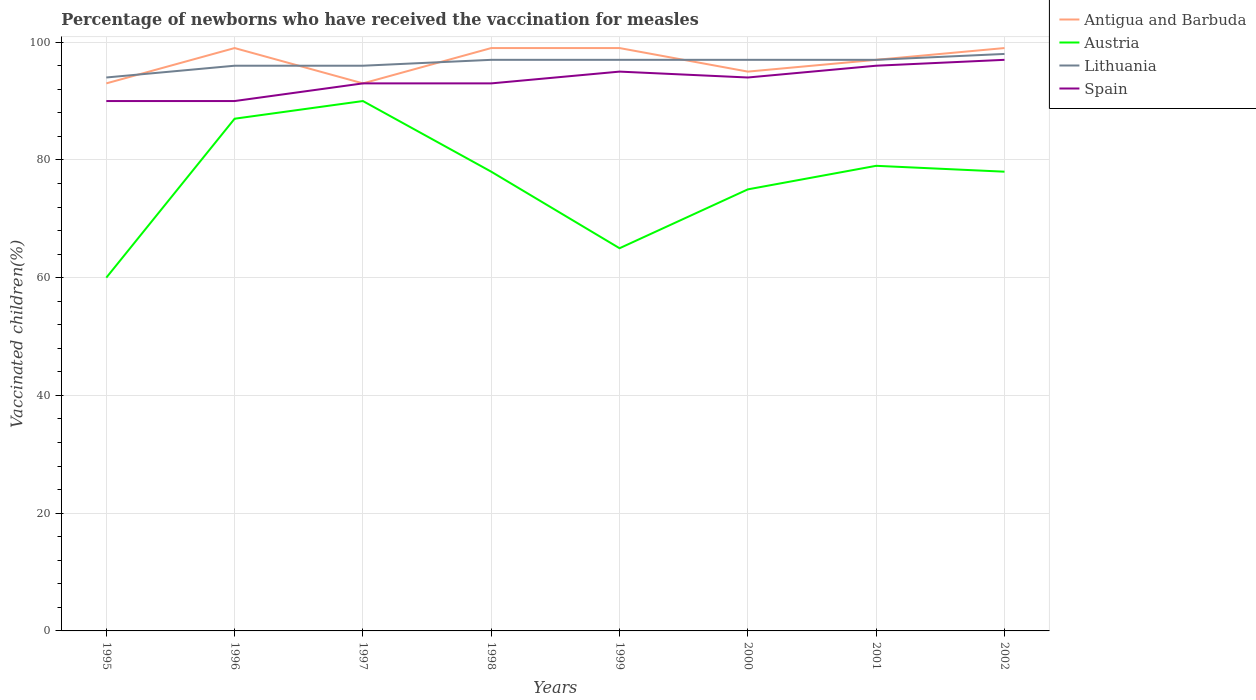Does the line corresponding to Spain intersect with the line corresponding to Antigua and Barbuda?
Keep it short and to the point. Yes. Across all years, what is the maximum percentage of vaccinated children in Spain?
Your response must be concise. 90. In which year was the percentage of vaccinated children in Spain maximum?
Your answer should be very brief. 1995. What is the difference between the highest and the second highest percentage of vaccinated children in Spain?
Provide a short and direct response. 7. How many lines are there?
Your response must be concise. 4. How many years are there in the graph?
Your answer should be very brief. 8. Are the values on the major ticks of Y-axis written in scientific E-notation?
Give a very brief answer. No. Does the graph contain any zero values?
Your answer should be compact. No. Where does the legend appear in the graph?
Your answer should be compact. Top right. How many legend labels are there?
Provide a succinct answer. 4. How are the legend labels stacked?
Make the answer very short. Vertical. What is the title of the graph?
Provide a succinct answer. Percentage of newborns who have received the vaccination for measles. Does "Algeria" appear as one of the legend labels in the graph?
Offer a terse response. No. What is the label or title of the Y-axis?
Provide a succinct answer. Vaccinated children(%). What is the Vaccinated children(%) of Antigua and Barbuda in 1995?
Keep it short and to the point. 93. What is the Vaccinated children(%) of Austria in 1995?
Your answer should be compact. 60. What is the Vaccinated children(%) in Lithuania in 1995?
Your answer should be very brief. 94. What is the Vaccinated children(%) in Spain in 1995?
Your answer should be compact. 90. What is the Vaccinated children(%) in Antigua and Barbuda in 1996?
Keep it short and to the point. 99. What is the Vaccinated children(%) of Austria in 1996?
Your answer should be very brief. 87. What is the Vaccinated children(%) in Lithuania in 1996?
Your answer should be compact. 96. What is the Vaccinated children(%) of Antigua and Barbuda in 1997?
Keep it short and to the point. 93. What is the Vaccinated children(%) in Austria in 1997?
Ensure brevity in your answer.  90. What is the Vaccinated children(%) of Lithuania in 1997?
Your response must be concise. 96. What is the Vaccinated children(%) in Spain in 1997?
Your answer should be very brief. 93. What is the Vaccinated children(%) in Lithuania in 1998?
Your answer should be compact. 97. What is the Vaccinated children(%) in Spain in 1998?
Offer a very short reply. 93. What is the Vaccinated children(%) of Antigua and Barbuda in 1999?
Your response must be concise. 99. What is the Vaccinated children(%) of Lithuania in 1999?
Keep it short and to the point. 97. What is the Vaccinated children(%) in Spain in 1999?
Give a very brief answer. 95. What is the Vaccinated children(%) in Antigua and Barbuda in 2000?
Provide a succinct answer. 95. What is the Vaccinated children(%) of Austria in 2000?
Provide a succinct answer. 75. What is the Vaccinated children(%) of Lithuania in 2000?
Your response must be concise. 97. What is the Vaccinated children(%) in Spain in 2000?
Your answer should be very brief. 94. What is the Vaccinated children(%) in Antigua and Barbuda in 2001?
Make the answer very short. 97. What is the Vaccinated children(%) in Austria in 2001?
Give a very brief answer. 79. What is the Vaccinated children(%) of Lithuania in 2001?
Keep it short and to the point. 97. What is the Vaccinated children(%) in Spain in 2001?
Provide a short and direct response. 96. What is the Vaccinated children(%) in Antigua and Barbuda in 2002?
Provide a short and direct response. 99. What is the Vaccinated children(%) in Lithuania in 2002?
Your answer should be very brief. 98. What is the Vaccinated children(%) in Spain in 2002?
Your answer should be very brief. 97. Across all years, what is the maximum Vaccinated children(%) of Antigua and Barbuda?
Provide a succinct answer. 99. Across all years, what is the maximum Vaccinated children(%) in Lithuania?
Provide a succinct answer. 98. Across all years, what is the maximum Vaccinated children(%) in Spain?
Your answer should be compact. 97. Across all years, what is the minimum Vaccinated children(%) of Antigua and Barbuda?
Your answer should be compact. 93. Across all years, what is the minimum Vaccinated children(%) in Lithuania?
Ensure brevity in your answer.  94. What is the total Vaccinated children(%) in Antigua and Barbuda in the graph?
Make the answer very short. 774. What is the total Vaccinated children(%) in Austria in the graph?
Your response must be concise. 612. What is the total Vaccinated children(%) in Lithuania in the graph?
Provide a short and direct response. 772. What is the total Vaccinated children(%) of Spain in the graph?
Your response must be concise. 748. What is the difference between the Vaccinated children(%) in Antigua and Barbuda in 1995 and that in 1996?
Provide a succinct answer. -6. What is the difference between the Vaccinated children(%) of Austria in 1995 and that in 1996?
Give a very brief answer. -27. What is the difference between the Vaccinated children(%) in Lithuania in 1995 and that in 1996?
Your response must be concise. -2. What is the difference between the Vaccinated children(%) in Spain in 1995 and that in 1996?
Offer a very short reply. 0. What is the difference between the Vaccinated children(%) of Austria in 1995 and that in 1997?
Offer a very short reply. -30. What is the difference between the Vaccinated children(%) in Lithuania in 1995 and that in 1997?
Offer a terse response. -2. What is the difference between the Vaccinated children(%) in Spain in 1995 and that in 1998?
Offer a terse response. -3. What is the difference between the Vaccinated children(%) in Antigua and Barbuda in 1995 and that in 1999?
Your answer should be very brief. -6. What is the difference between the Vaccinated children(%) of Austria in 1995 and that in 1999?
Keep it short and to the point. -5. What is the difference between the Vaccinated children(%) in Lithuania in 1995 and that in 1999?
Offer a very short reply. -3. What is the difference between the Vaccinated children(%) in Antigua and Barbuda in 1995 and that in 2000?
Offer a terse response. -2. What is the difference between the Vaccinated children(%) in Austria in 1995 and that in 2000?
Provide a short and direct response. -15. What is the difference between the Vaccinated children(%) in Lithuania in 1995 and that in 2000?
Give a very brief answer. -3. What is the difference between the Vaccinated children(%) of Antigua and Barbuda in 1995 and that in 2001?
Keep it short and to the point. -4. What is the difference between the Vaccinated children(%) in Lithuania in 1995 and that in 2001?
Give a very brief answer. -3. What is the difference between the Vaccinated children(%) in Spain in 1995 and that in 2001?
Make the answer very short. -6. What is the difference between the Vaccinated children(%) of Austria in 1995 and that in 2002?
Your answer should be compact. -18. What is the difference between the Vaccinated children(%) in Spain in 1995 and that in 2002?
Provide a succinct answer. -7. What is the difference between the Vaccinated children(%) of Antigua and Barbuda in 1996 and that in 1997?
Your response must be concise. 6. What is the difference between the Vaccinated children(%) of Austria in 1996 and that in 1997?
Offer a very short reply. -3. What is the difference between the Vaccinated children(%) of Antigua and Barbuda in 1996 and that in 1998?
Give a very brief answer. 0. What is the difference between the Vaccinated children(%) in Austria in 1996 and that in 1998?
Provide a succinct answer. 9. What is the difference between the Vaccinated children(%) of Lithuania in 1996 and that in 1998?
Your answer should be very brief. -1. What is the difference between the Vaccinated children(%) in Antigua and Barbuda in 1996 and that in 1999?
Your answer should be compact. 0. What is the difference between the Vaccinated children(%) of Austria in 1996 and that in 1999?
Provide a succinct answer. 22. What is the difference between the Vaccinated children(%) of Lithuania in 1996 and that in 1999?
Make the answer very short. -1. What is the difference between the Vaccinated children(%) in Spain in 1996 and that in 2000?
Your answer should be compact. -4. What is the difference between the Vaccinated children(%) of Antigua and Barbuda in 1996 and that in 2002?
Your response must be concise. 0. What is the difference between the Vaccinated children(%) in Lithuania in 1996 and that in 2002?
Offer a terse response. -2. What is the difference between the Vaccinated children(%) of Spain in 1996 and that in 2002?
Your response must be concise. -7. What is the difference between the Vaccinated children(%) of Austria in 1997 and that in 1998?
Give a very brief answer. 12. What is the difference between the Vaccinated children(%) in Lithuania in 1997 and that in 1998?
Provide a succinct answer. -1. What is the difference between the Vaccinated children(%) of Spain in 1997 and that in 1998?
Offer a terse response. 0. What is the difference between the Vaccinated children(%) of Austria in 1997 and that in 1999?
Provide a succinct answer. 25. What is the difference between the Vaccinated children(%) in Lithuania in 1997 and that in 1999?
Provide a succinct answer. -1. What is the difference between the Vaccinated children(%) in Spain in 1997 and that in 1999?
Ensure brevity in your answer.  -2. What is the difference between the Vaccinated children(%) in Antigua and Barbuda in 1997 and that in 2000?
Offer a very short reply. -2. What is the difference between the Vaccinated children(%) of Austria in 1997 and that in 2000?
Offer a very short reply. 15. What is the difference between the Vaccinated children(%) of Lithuania in 1997 and that in 2000?
Provide a short and direct response. -1. What is the difference between the Vaccinated children(%) in Antigua and Barbuda in 1997 and that in 2001?
Your answer should be very brief. -4. What is the difference between the Vaccinated children(%) of Lithuania in 1997 and that in 2001?
Make the answer very short. -1. What is the difference between the Vaccinated children(%) in Spain in 1997 and that in 2001?
Your answer should be compact. -3. What is the difference between the Vaccinated children(%) in Antigua and Barbuda in 1998 and that in 1999?
Offer a very short reply. 0. What is the difference between the Vaccinated children(%) in Lithuania in 1998 and that in 1999?
Provide a short and direct response. 0. What is the difference between the Vaccinated children(%) of Spain in 1998 and that in 2000?
Your answer should be very brief. -1. What is the difference between the Vaccinated children(%) of Austria in 1998 and that in 2001?
Provide a short and direct response. -1. What is the difference between the Vaccinated children(%) in Lithuania in 1998 and that in 2001?
Your answer should be very brief. 0. What is the difference between the Vaccinated children(%) of Spain in 1998 and that in 2002?
Make the answer very short. -4. What is the difference between the Vaccinated children(%) in Antigua and Barbuda in 1999 and that in 2000?
Give a very brief answer. 4. What is the difference between the Vaccinated children(%) of Lithuania in 1999 and that in 2000?
Your answer should be very brief. 0. What is the difference between the Vaccinated children(%) in Lithuania in 1999 and that in 2001?
Give a very brief answer. 0. What is the difference between the Vaccinated children(%) of Antigua and Barbuda in 1999 and that in 2002?
Keep it short and to the point. 0. What is the difference between the Vaccinated children(%) in Lithuania in 1999 and that in 2002?
Provide a short and direct response. -1. What is the difference between the Vaccinated children(%) of Spain in 1999 and that in 2002?
Provide a succinct answer. -2. What is the difference between the Vaccinated children(%) of Austria in 2000 and that in 2001?
Offer a terse response. -4. What is the difference between the Vaccinated children(%) in Spain in 2000 and that in 2001?
Provide a succinct answer. -2. What is the difference between the Vaccinated children(%) of Antigua and Barbuda in 2000 and that in 2002?
Your response must be concise. -4. What is the difference between the Vaccinated children(%) in Austria in 2000 and that in 2002?
Your answer should be very brief. -3. What is the difference between the Vaccinated children(%) of Lithuania in 2000 and that in 2002?
Give a very brief answer. -1. What is the difference between the Vaccinated children(%) in Spain in 2000 and that in 2002?
Your response must be concise. -3. What is the difference between the Vaccinated children(%) in Austria in 2001 and that in 2002?
Your answer should be very brief. 1. What is the difference between the Vaccinated children(%) in Antigua and Barbuda in 1995 and the Vaccinated children(%) in Austria in 1996?
Your answer should be compact. 6. What is the difference between the Vaccinated children(%) of Antigua and Barbuda in 1995 and the Vaccinated children(%) of Spain in 1996?
Offer a very short reply. 3. What is the difference between the Vaccinated children(%) in Austria in 1995 and the Vaccinated children(%) in Lithuania in 1996?
Offer a terse response. -36. What is the difference between the Vaccinated children(%) in Lithuania in 1995 and the Vaccinated children(%) in Spain in 1996?
Offer a very short reply. 4. What is the difference between the Vaccinated children(%) in Antigua and Barbuda in 1995 and the Vaccinated children(%) in Austria in 1997?
Your response must be concise. 3. What is the difference between the Vaccinated children(%) in Austria in 1995 and the Vaccinated children(%) in Lithuania in 1997?
Your response must be concise. -36. What is the difference between the Vaccinated children(%) in Austria in 1995 and the Vaccinated children(%) in Spain in 1997?
Keep it short and to the point. -33. What is the difference between the Vaccinated children(%) in Lithuania in 1995 and the Vaccinated children(%) in Spain in 1997?
Your response must be concise. 1. What is the difference between the Vaccinated children(%) in Austria in 1995 and the Vaccinated children(%) in Lithuania in 1998?
Make the answer very short. -37. What is the difference between the Vaccinated children(%) in Austria in 1995 and the Vaccinated children(%) in Spain in 1998?
Provide a short and direct response. -33. What is the difference between the Vaccinated children(%) of Lithuania in 1995 and the Vaccinated children(%) of Spain in 1998?
Offer a very short reply. 1. What is the difference between the Vaccinated children(%) of Antigua and Barbuda in 1995 and the Vaccinated children(%) of Austria in 1999?
Your answer should be very brief. 28. What is the difference between the Vaccinated children(%) of Antigua and Barbuda in 1995 and the Vaccinated children(%) of Lithuania in 1999?
Your answer should be compact. -4. What is the difference between the Vaccinated children(%) of Antigua and Barbuda in 1995 and the Vaccinated children(%) of Spain in 1999?
Your answer should be very brief. -2. What is the difference between the Vaccinated children(%) in Austria in 1995 and the Vaccinated children(%) in Lithuania in 1999?
Offer a terse response. -37. What is the difference between the Vaccinated children(%) of Austria in 1995 and the Vaccinated children(%) of Spain in 1999?
Offer a terse response. -35. What is the difference between the Vaccinated children(%) in Antigua and Barbuda in 1995 and the Vaccinated children(%) in Austria in 2000?
Your answer should be compact. 18. What is the difference between the Vaccinated children(%) in Antigua and Barbuda in 1995 and the Vaccinated children(%) in Spain in 2000?
Ensure brevity in your answer.  -1. What is the difference between the Vaccinated children(%) of Austria in 1995 and the Vaccinated children(%) of Lithuania in 2000?
Provide a short and direct response. -37. What is the difference between the Vaccinated children(%) in Austria in 1995 and the Vaccinated children(%) in Spain in 2000?
Offer a terse response. -34. What is the difference between the Vaccinated children(%) of Antigua and Barbuda in 1995 and the Vaccinated children(%) of Austria in 2001?
Make the answer very short. 14. What is the difference between the Vaccinated children(%) of Austria in 1995 and the Vaccinated children(%) of Lithuania in 2001?
Keep it short and to the point. -37. What is the difference between the Vaccinated children(%) of Austria in 1995 and the Vaccinated children(%) of Spain in 2001?
Keep it short and to the point. -36. What is the difference between the Vaccinated children(%) of Lithuania in 1995 and the Vaccinated children(%) of Spain in 2001?
Provide a short and direct response. -2. What is the difference between the Vaccinated children(%) of Antigua and Barbuda in 1995 and the Vaccinated children(%) of Austria in 2002?
Ensure brevity in your answer.  15. What is the difference between the Vaccinated children(%) in Antigua and Barbuda in 1995 and the Vaccinated children(%) in Lithuania in 2002?
Give a very brief answer. -5. What is the difference between the Vaccinated children(%) of Antigua and Barbuda in 1995 and the Vaccinated children(%) of Spain in 2002?
Your response must be concise. -4. What is the difference between the Vaccinated children(%) in Austria in 1995 and the Vaccinated children(%) in Lithuania in 2002?
Offer a very short reply. -38. What is the difference between the Vaccinated children(%) of Austria in 1995 and the Vaccinated children(%) of Spain in 2002?
Offer a terse response. -37. What is the difference between the Vaccinated children(%) of Antigua and Barbuda in 1996 and the Vaccinated children(%) of Austria in 1997?
Provide a succinct answer. 9. What is the difference between the Vaccinated children(%) in Antigua and Barbuda in 1996 and the Vaccinated children(%) in Lithuania in 1997?
Provide a succinct answer. 3. What is the difference between the Vaccinated children(%) of Antigua and Barbuda in 1996 and the Vaccinated children(%) of Spain in 1997?
Provide a succinct answer. 6. What is the difference between the Vaccinated children(%) in Antigua and Barbuda in 1996 and the Vaccinated children(%) in Lithuania in 1998?
Your answer should be compact. 2. What is the difference between the Vaccinated children(%) in Antigua and Barbuda in 1996 and the Vaccinated children(%) in Spain in 1998?
Provide a succinct answer. 6. What is the difference between the Vaccinated children(%) of Austria in 1996 and the Vaccinated children(%) of Lithuania in 1998?
Provide a short and direct response. -10. What is the difference between the Vaccinated children(%) of Antigua and Barbuda in 1996 and the Vaccinated children(%) of Austria in 1999?
Make the answer very short. 34. What is the difference between the Vaccinated children(%) in Antigua and Barbuda in 1996 and the Vaccinated children(%) in Spain in 1999?
Ensure brevity in your answer.  4. What is the difference between the Vaccinated children(%) of Austria in 1996 and the Vaccinated children(%) of Spain in 1999?
Give a very brief answer. -8. What is the difference between the Vaccinated children(%) of Antigua and Barbuda in 1996 and the Vaccinated children(%) of Austria in 2000?
Keep it short and to the point. 24. What is the difference between the Vaccinated children(%) in Antigua and Barbuda in 1996 and the Vaccinated children(%) in Lithuania in 2000?
Offer a terse response. 2. What is the difference between the Vaccinated children(%) in Antigua and Barbuda in 1996 and the Vaccinated children(%) in Spain in 2000?
Provide a short and direct response. 5. What is the difference between the Vaccinated children(%) in Austria in 1996 and the Vaccinated children(%) in Spain in 2000?
Make the answer very short. -7. What is the difference between the Vaccinated children(%) in Antigua and Barbuda in 1996 and the Vaccinated children(%) in Lithuania in 2001?
Your response must be concise. 2. What is the difference between the Vaccinated children(%) of Antigua and Barbuda in 1996 and the Vaccinated children(%) of Spain in 2001?
Give a very brief answer. 3. What is the difference between the Vaccinated children(%) in Antigua and Barbuda in 1996 and the Vaccinated children(%) in Austria in 2002?
Keep it short and to the point. 21. What is the difference between the Vaccinated children(%) in Antigua and Barbuda in 1996 and the Vaccinated children(%) in Spain in 2002?
Make the answer very short. 2. What is the difference between the Vaccinated children(%) of Austria in 1996 and the Vaccinated children(%) of Lithuania in 2002?
Keep it short and to the point. -11. What is the difference between the Vaccinated children(%) of Austria in 1996 and the Vaccinated children(%) of Spain in 2002?
Offer a very short reply. -10. What is the difference between the Vaccinated children(%) in Lithuania in 1996 and the Vaccinated children(%) in Spain in 2002?
Make the answer very short. -1. What is the difference between the Vaccinated children(%) in Antigua and Barbuda in 1997 and the Vaccinated children(%) in Austria in 1998?
Your answer should be compact. 15. What is the difference between the Vaccinated children(%) in Antigua and Barbuda in 1997 and the Vaccinated children(%) in Lithuania in 1998?
Offer a very short reply. -4. What is the difference between the Vaccinated children(%) of Antigua and Barbuda in 1997 and the Vaccinated children(%) of Austria in 1999?
Your answer should be very brief. 28. What is the difference between the Vaccinated children(%) of Austria in 1997 and the Vaccinated children(%) of Lithuania in 1999?
Make the answer very short. -7. What is the difference between the Vaccinated children(%) of Austria in 1997 and the Vaccinated children(%) of Spain in 1999?
Make the answer very short. -5. What is the difference between the Vaccinated children(%) in Antigua and Barbuda in 1997 and the Vaccinated children(%) in Spain in 2000?
Your answer should be compact. -1. What is the difference between the Vaccinated children(%) of Austria in 1997 and the Vaccinated children(%) of Lithuania in 2000?
Your answer should be very brief. -7. What is the difference between the Vaccinated children(%) in Austria in 1997 and the Vaccinated children(%) in Spain in 2000?
Offer a very short reply. -4. What is the difference between the Vaccinated children(%) in Antigua and Barbuda in 1997 and the Vaccinated children(%) in Austria in 2001?
Provide a succinct answer. 14. What is the difference between the Vaccinated children(%) of Antigua and Barbuda in 1997 and the Vaccinated children(%) of Lithuania in 2001?
Give a very brief answer. -4. What is the difference between the Vaccinated children(%) in Austria in 1997 and the Vaccinated children(%) in Lithuania in 2001?
Ensure brevity in your answer.  -7. What is the difference between the Vaccinated children(%) of Lithuania in 1997 and the Vaccinated children(%) of Spain in 2001?
Ensure brevity in your answer.  0. What is the difference between the Vaccinated children(%) of Antigua and Barbuda in 1997 and the Vaccinated children(%) of Austria in 2002?
Your response must be concise. 15. What is the difference between the Vaccinated children(%) of Antigua and Barbuda in 1997 and the Vaccinated children(%) of Lithuania in 2002?
Ensure brevity in your answer.  -5. What is the difference between the Vaccinated children(%) of Antigua and Barbuda in 1997 and the Vaccinated children(%) of Spain in 2002?
Provide a short and direct response. -4. What is the difference between the Vaccinated children(%) in Lithuania in 1997 and the Vaccinated children(%) in Spain in 2002?
Your response must be concise. -1. What is the difference between the Vaccinated children(%) of Antigua and Barbuda in 1998 and the Vaccinated children(%) of Lithuania in 1999?
Offer a very short reply. 2. What is the difference between the Vaccinated children(%) of Antigua and Barbuda in 1998 and the Vaccinated children(%) of Spain in 1999?
Your response must be concise. 4. What is the difference between the Vaccinated children(%) in Austria in 1998 and the Vaccinated children(%) in Spain in 1999?
Ensure brevity in your answer.  -17. What is the difference between the Vaccinated children(%) of Antigua and Barbuda in 1998 and the Vaccinated children(%) of Austria in 2000?
Your response must be concise. 24. What is the difference between the Vaccinated children(%) of Antigua and Barbuda in 1998 and the Vaccinated children(%) of Lithuania in 2000?
Keep it short and to the point. 2. What is the difference between the Vaccinated children(%) of Austria in 1998 and the Vaccinated children(%) of Lithuania in 2000?
Give a very brief answer. -19. What is the difference between the Vaccinated children(%) of Austria in 1998 and the Vaccinated children(%) of Spain in 2000?
Provide a succinct answer. -16. What is the difference between the Vaccinated children(%) of Lithuania in 1998 and the Vaccinated children(%) of Spain in 2000?
Offer a terse response. 3. What is the difference between the Vaccinated children(%) in Antigua and Barbuda in 1998 and the Vaccinated children(%) in Spain in 2001?
Keep it short and to the point. 3. What is the difference between the Vaccinated children(%) in Antigua and Barbuda in 1998 and the Vaccinated children(%) in Austria in 2002?
Offer a terse response. 21. What is the difference between the Vaccinated children(%) in Antigua and Barbuda in 1998 and the Vaccinated children(%) in Lithuania in 2002?
Your response must be concise. 1. What is the difference between the Vaccinated children(%) in Austria in 1998 and the Vaccinated children(%) in Spain in 2002?
Offer a very short reply. -19. What is the difference between the Vaccinated children(%) of Antigua and Barbuda in 1999 and the Vaccinated children(%) of Austria in 2000?
Make the answer very short. 24. What is the difference between the Vaccinated children(%) in Antigua and Barbuda in 1999 and the Vaccinated children(%) in Spain in 2000?
Offer a very short reply. 5. What is the difference between the Vaccinated children(%) in Austria in 1999 and the Vaccinated children(%) in Lithuania in 2000?
Your answer should be very brief. -32. What is the difference between the Vaccinated children(%) of Austria in 1999 and the Vaccinated children(%) of Spain in 2000?
Provide a short and direct response. -29. What is the difference between the Vaccinated children(%) in Antigua and Barbuda in 1999 and the Vaccinated children(%) in Austria in 2001?
Give a very brief answer. 20. What is the difference between the Vaccinated children(%) in Antigua and Barbuda in 1999 and the Vaccinated children(%) in Spain in 2001?
Keep it short and to the point. 3. What is the difference between the Vaccinated children(%) in Austria in 1999 and the Vaccinated children(%) in Lithuania in 2001?
Provide a succinct answer. -32. What is the difference between the Vaccinated children(%) of Austria in 1999 and the Vaccinated children(%) of Spain in 2001?
Keep it short and to the point. -31. What is the difference between the Vaccinated children(%) in Lithuania in 1999 and the Vaccinated children(%) in Spain in 2001?
Your answer should be compact. 1. What is the difference between the Vaccinated children(%) of Antigua and Barbuda in 1999 and the Vaccinated children(%) of Lithuania in 2002?
Your response must be concise. 1. What is the difference between the Vaccinated children(%) in Antigua and Barbuda in 1999 and the Vaccinated children(%) in Spain in 2002?
Provide a succinct answer. 2. What is the difference between the Vaccinated children(%) of Austria in 1999 and the Vaccinated children(%) of Lithuania in 2002?
Offer a very short reply. -33. What is the difference between the Vaccinated children(%) of Austria in 1999 and the Vaccinated children(%) of Spain in 2002?
Provide a short and direct response. -32. What is the difference between the Vaccinated children(%) of Lithuania in 1999 and the Vaccinated children(%) of Spain in 2002?
Offer a very short reply. 0. What is the difference between the Vaccinated children(%) in Antigua and Barbuda in 2000 and the Vaccinated children(%) in Austria in 2001?
Provide a short and direct response. 16. What is the difference between the Vaccinated children(%) of Antigua and Barbuda in 2000 and the Vaccinated children(%) of Spain in 2001?
Provide a short and direct response. -1. What is the difference between the Vaccinated children(%) in Austria in 2000 and the Vaccinated children(%) in Spain in 2001?
Offer a terse response. -21. What is the difference between the Vaccinated children(%) in Lithuania in 2000 and the Vaccinated children(%) in Spain in 2001?
Give a very brief answer. 1. What is the difference between the Vaccinated children(%) of Antigua and Barbuda in 2000 and the Vaccinated children(%) of Austria in 2002?
Offer a very short reply. 17. What is the difference between the Vaccinated children(%) in Antigua and Barbuda in 2000 and the Vaccinated children(%) in Lithuania in 2002?
Give a very brief answer. -3. What is the difference between the Vaccinated children(%) of Austria in 2000 and the Vaccinated children(%) of Lithuania in 2002?
Offer a very short reply. -23. What is the difference between the Vaccinated children(%) in Lithuania in 2000 and the Vaccinated children(%) in Spain in 2002?
Offer a very short reply. 0. What is the difference between the Vaccinated children(%) in Antigua and Barbuda in 2001 and the Vaccinated children(%) in Spain in 2002?
Your answer should be compact. 0. What is the difference between the Vaccinated children(%) in Austria in 2001 and the Vaccinated children(%) in Lithuania in 2002?
Make the answer very short. -19. What is the difference between the Vaccinated children(%) of Lithuania in 2001 and the Vaccinated children(%) of Spain in 2002?
Your answer should be compact. 0. What is the average Vaccinated children(%) in Antigua and Barbuda per year?
Ensure brevity in your answer.  96.75. What is the average Vaccinated children(%) in Austria per year?
Offer a very short reply. 76.5. What is the average Vaccinated children(%) in Lithuania per year?
Make the answer very short. 96.5. What is the average Vaccinated children(%) in Spain per year?
Offer a very short reply. 93.5. In the year 1995, what is the difference between the Vaccinated children(%) of Antigua and Barbuda and Vaccinated children(%) of Austria?
Keep it short and to the point. 33. In the year 1995, what is the difference between the Vaccinated children(%) of Austria and Vaccinated children(%) of Lithuania?
Provide a succinct answer. -34. In the year 1995, what is the difference between the Vaccinated children(%) in Austria and Vaccinated children(%) in Spain?
Ensure brevity in your answer.  -30. In the year 1995, what is the difference between the Vaccinated children(%) in Lithuania and Vaccinated children(%) in Spain?
Offer a very short reply. 4. In the year 1996, what is the difference between the Vaccinated children(%) in Antigua and Barbuda and Vaccinated children(%) in Austria?
Give a very brief answer. 12. In the year 1996, what is the difference between the Vaccinated children(%) of Austria and Vaccinated children(%) of Lithuania?
Make the answer very short. -9. In the year 1996, what is the difference between the Vaccinated children(%) in Austria and Vaccinated children(%) in Spain?
Give a very brief answer. -3. In the year 1996, what is the difference between the Vaccinated children(%) of Lithuania and Vaccinated children(%) of Spain?
Your response must be concise. 6. In the year 1997, what is the difference between the Vaccinated children(%) of Antigua and Barbuda and Vaccinated children(%) of Austria?
Offer a terse response. 3. In the year 1997, what is the difference between the Vaccinated children(%) of Antigua and Barbuda and Vaccinated children(%) of Lithuania?
Offer a very short reply. -3. In the year 1997, what is the difference between the Vaccinated children(%) of Austria and Vaccinated children(%) of Lithuania?
Offer a very short reply. -6. In the year 1998, what is the difference between the Vaccinated children(%) of Lithuania and Vaccinated children(%) of Spain?
Your answer should be very brief. 4. In the year 1999, what is the difference between the Vaccinated children(%) of Antigua and Barbuda and Vaccinated children(%) of Lithuania?
Keep it short and to the point. 2. In the year 1999, what is the difference between the Vaccinated children(%) of Austria and Vaccinated children(%) of Lithuania?
Your response must be concise. -32. In the year 1999, what is the difference between the Vaccinated children(%) in Austria and Vaccinated children(%) in Spain?
Ensure brevity in your answer.  -30. In the year 2000, what is the difference between the Vaccinated children(%) in Antigua and Barbuda and Vaccinated children(%) in Lithuania?
Offer a very short reply. -2. In the year 2000, what is the difference between the Vaccinated children(%) in Antigua and Barbuda and Vaccinated children(%) in Spain?
Your answer should be compact. 1. In the year 2000, what is the difference between the Vaccinated children(%) of Austria and Vaccinated children(%) of Lithuania?
Provide a short and direct response. -22. In the year 2001, what is the difference between the Vaccinated children(%) in Antigua and Barbuda and Vaccinated children(%) in Austria?
Offer a terse response. 18. In the year 2001, what is the difference between the Vaccinated children(%) in Antigua and Barbuda and Vaccinated children(%) in Lithuania?
Make the answer very short. 0. In the year 2001, what is the difference between the Vaccinated children(%) in Austria and Vaccinated children(%) in Lithuania?
Make the answer very short. -18. In the year 2002, what is the difference between the Vaccinated children(%) in Antigua and Barbuda and Vaccinated children(%) in Lithuania?
Provide a short and direct response. 1. In the year 2002, what is the difference between the Vaccinated children(%) in Antigua and Barbuda and Vaccinated children(%) in Spain?
Provide a succinct answer. 2. In the year 2002, what is the difference between the Vaccinated children(%) of Austria and Vaccinated children(%) of Lithuania?
Give a very brief answer. -20. What is the ratio of the Vaccinated children(%) in Antigua and Barbuda in 1995 to that in 1996?
Ensure brevity in your answer.  0.94. What is the ratio of the Vaccinated children(%) of Austria in 1995 to that in 1996?
Provide a succinct answer. 0.69. What is the ratio of the Vaccinated children(%) in Lithuania in 1995 to that in 1996?
Provide a succinct answer. 0.98. What is the ratio of the Vaccinated children(%) in Spain in 1995 to that in 1996?
Keep it short and to the point. 1. What is the ratio of the Vaccinated children(%) of Lithuania in 1995 to that in 1997?
Provide a succinct answer. 0.98. What is the ratio of the Vaccinated children(%) in Spain in 1995 to that in 1997?
Provide a short and direct response. 0.97. What is the ratio of the Vaccinated children(%) in Antigua and Barbuda in 1995 to that in 1998?
Provide a succinct answer. 0.94. What is the ratio of the Vaccinated children(%) of Austria in 1995 to that in 1998?
Provide a succinct answer. 0.77. What is the ratio of the Vaccinated children(%) in Lithuania in 1995 to that in 1998?
Your response must be concise. 0.97. What is the ratio of the Vaccinated children(%) in Spain in 1995 to that in 1998?
Provide a succinct answer. 0.97. What is the ratio of the Vaccinated children(%) in Antigua and Barbuda in 1995 to that in 1999?
Your answer should be very brief. 0.94. What is the ratio of the Vaccinated children(%) in Lithuania in 1995 to that in 1999?
Keep it short and to the point. 0.97. What is the ratio of the Vaccinated children(%) in Antigua and Barbuda in 1995 to that in 2000?
Give a very brief answer. 0.98. What is the ratio of the Vaccinated children(%) in Austria in 1995 to that in 2000?
Provide a succinct answer. 0.8. What is the ratio of the Vaccinated children(%) in Lithuania in 1995 to that in 2000?
Your answer should be very brief. 0.97. What is the ratio of the Vaccinated children(%) in Spain in 1995 to that in 2000?
Offer a very short reply. 0.96. What is the ratio of the Vaccinated children(%) in Antigua and Barbuda in 1995 to that in 2001?
Offer a terse response. 0.96. What is the ratio of the Vaccinated children(%) of Austria in 1995 to that in 2001?
Provide a succinct answer. 0.76. What is the ratio of the Vaccinated children(%) of Lithuania in 1995 to that in 2001?
Your answer should be compact. 0.97. What is the ratio of the Vaccinated children(%) of Spain in 1995 to that in 2001?
Offer a terse response. 0.94. What is the ratio of the Vaccinated children(%) in Antigua and Barbuda in 1995 to that in 2002?
Offer a terse response. 0.94. What is the ratio of the Vaccinated children(%) of Austria in 1995 to that in 2002?
Offer a terse response. 0.77. What is the ratio of the Vaccinated children(%) in Lithuania in 1995 to that in 2002?
Your response must be concise. 0.96. What is the ratio of the Vaccinated children(%) of Spain in 1995 to that in 2002?
Keep it short and to the point. 0.93. What is the ratio of the Vaccinated children(%) of Antigua and Barbuda in 1996 to that in 1997?
Make the answer very short. 1.06. What is the ratio of the Vaccinated children(%) of Austria in 1996 to that in 1997?
Your answer should be compact. 0.97. What is the ratio of the Vaccinated children(%) in Antigua and Barbuda in 1996 to that in 1998?
Keep it short and to the point. 1. What is the ratio of the Vaccinated children(%) of Austria in 1996 to that in 1998?
Offer a terse response. 1.12. What is the ratio of the Vaccinated children(%) in Austria in 1996 to that in 1999?
Provide a succinct answer. 1.34. What is the ratio of the Vaccinated children(%) in Lithuania in 1996 to that in 1999?
Give a very brief answer. 0.99. What is the ratio of the Vaccinated children(%) of Spain in 1996 to that in 1999?
Provide a succinct answer. 0.95. What is the ratio of the Vaccinated children(%) in Antigua and Barbuda in 1996 to that in 2000?
Offer a terse response. 1.04. What is the ratio of the Vaccinated children(%) in Austria in 1996 to that in 2000?
Provide a short and direct response. 1.16. What is the ratio of the Vaccinated children(%) of Spain in 1996 to that in 2000?
Offer a very short reply. 0.96. What is the ratio of the Vaccinated children(%) of Antigua and Barbuda in 1996 to that in 2001?
Give a very brief answer. 1.02. What is the ratio of the Vaccinated children(%) of Austria in 1996 to that in 2001?
Provide a succinct answer. 1.1. What is the ratio of the Vaccinated children(%) of Lithuania in 1996 to that in 2001?
Provide a short and direct response. 0.99. What is the ratio of the Vaccinated children(%) of Spain in 1996 to that in 2001?
Make the answer very short. 0.94. What is the ratio of the Vaccinated children(%) of Antigua and Barbuda in 1996 to that in 2002?
Give a very brief answer. 1. What is the ratio of the Vaccinated children(%) of Austria in 1996 to that in 2002?
Provide a succinct answer. 1.12. What is the ratio of the Vaccinated children(%) in Lithuania in 1996 to that in 2002?
Provide a short and direct response. 0.98. What is the ratio of the Vaccinated children(%) of Spain in 1996 to that in 2002?
Give a very brief answer. 0.93. What is the ratio of the Vaccinated children(%) in Antigua and Barbuda in 1997 to that in 1998?
Your answer should be very brief. 0.94. What is the ratio of the Vaccinated children(%) of Austria in 1997 to that in 1998?
Provide a succinct answer. 1.15. What is the ratio of the Vaccinated children(%) of Lithuania in 1997 to that in 1998?
Your answer should be very brief. 0.99. What is the ratio of the Vaccinated children(%) in Antigua and Barbuda in 1997 to that in 1999?
Your answer should be compact. 0.94. What is the ratio of the Vaccinated children(%) of Austria in 1997 to that in 1999?
Provide a short and direct response. 1.38. What is the ratio of the Vaccinated children(%) of Spain in 1997 to that in 1999?
Provide a short and direct response. 0.98. What is the ratio of the Vaccinated children(%) of Antigua and Barbuda in 1997 to that in 2000?
Provide a succinct answer. 0.98. What is the ratio of the Vaccinated children(%) of Austria in 1997 to that in 2000?
Offer a terse response. 1.2. What is the ratio of the Vaccinated children(%) of Lithuania in 1997 to that in 2000?
Keep it short and to the point. 0.99. What is the ratio of the Vaccinated children(%) in Antigua and Barbuda in 1997 to that in 2001?
Offer a very short reply. 0.96. What is the ratio of the Vaccinated children(%) in Austria in 1997 to that in 2001?
Ensure brevity in your answer.  1.14. What is the ratio of the Vaccinated children(%) of Lithuania in 1997 to that in 2001?
Keep it short and to the point. 0.99. What is the ratio of the Vaccinated children(%) of Spain in 1997 to that in 2001?
Keep it short and to the point. 0.97. What is the ratio of the Vaccinated children(%) of Antigua and Barbuda in 1997 to that in 2002?
Your response must be concise. 0.94. What is the ratio of the Vaccinated children(%) in Austria in 1997 to that in 2002?
Make the answer very short. 1.15. What is the ratio of the Vaccinated children(%) of Lithuania in 1997 to that in 2002?
Make the answer very short. 0.98. What is the ratio of the Vaccinated children(%) of Spain in 1997 to that in 2002?
Make the answer very short. 0.96. What is the ratio of the Vaccinated children(%) in Austria in 1998 to that in 1999?
Your response must be concise. 1.2. What is the ratio of the Vaccinated children(%) in Spain in 1998 to that in 1999?
Your answer should be compact. 0.98. What is the ratio of the Vaccinated children(%) in Antigua and Barbuda in 1998 to that in 2000?
Offer a very short reply. 1.04. What is the ratio of the Vaccinated children(%) of Austria in 1998 to that in 2000?
Give a very brief answer. 1.04. What is the ratio of the Vaccinated children(%) of Lithuania in 1998 to that in 2000?
Offer a terse response. 1. What is the ratio of the Vaccinated children(%) of Spain in 1998 to that in 2000?
Provide a short and direct response. 0.99. What is the ratio of the Vaccinated children(%) of Antigua and Barbuda in 1998 to that in 2001?
Ensure brevity in your answer.  1.02. What is the ratio of the Vaccinated children(%) in Austria in 1998 to that in 2001?
Keep it short and to the point. 0.99. What is the ratio of the Vaccinated children(%) in Spain in 1998 to that in 2001?
Give a very brief answer. 0.97. What is the ratio of the Vaccinated children(%) in Spain in 1998 to that in 2002?
Offer a terse response. 0.96. What is the ratio of the Vaccinated children(%) of Antigua and Barbuda in 1999 to that in 2000?
Offer a terse response. 1.04. What is the ratio of the Vaccinated children(%) of Austria in 1999 to that in 2000?
Give a very brief answer. 0.87. What is the ratio of the Vaccinated children(%) in Spain in 1999 to that in 2000?
Provide a succinct answer. 1.01. What is the ratio of the Vaccinated children(%) in Antigua and Barbuda in 1999 to that in 2001?
Ensure brevity in your answer.  1.02. What is the ratio of the Vaccinated children(%) of Austria in 1999 to that in 2001?
Offer a very short reply. 0.82. What is the ratio of the Vaccinated children(%) in Lithuania in 1999 to that in 2001?
Provide a succinct answer. 1. What is the ratio of the Vaccinated children(%) in Spain in 1999 to that in 2001?
Offer a very short reply. 0.99. What is the ratio of the Vaccinated children(%) of Austria in 1999 to that in 2002?
Offer a terse response. 0.83. What is the ratio of the Vaccinated children(%) in Lithuania in 1999 to that in 2002?
Your answer should be compact. 0.99. What is the ratio of the Vaccinated children(%) in Spain in 1999 to that in 2002?
Provide a succinct answer. 0.98. What is the ratio of the Vaccinated children(%) in Antigua and Barbuda in 2000 to that in 2001?
Your response must be concise. 0.98. What is the ratio of the Vaccinated children(%) in Austria in 2000 to that in 2001?
Offer a very short reply. 0.95. What is the ratio of the Vaccinated children(%) in Lithuania in 2000 to that in 2001?
Offer a terse response. 1. What is the ratio of the Vaccinated children(%) of Spain in 2000 to that in 2001?
Your response must be concise. 0.98. What is the ratio of the Vaccinated children(%) in Antigua and Barbuda in 2000 to that in 2002?
Keep it short and to the point. 0.96. What is the ratio of the Vaccinated children(%) in Austria in 2000 to that in 2002?
Your answer should be very brief. 0.96. What is the ratio of the Vaccinated children(%) in Spain in 2000 to that in 2002?
Keep it short and to the point. 0.97. What is the ratio of the Vaccinated children(%) in Antigua and Barbuda in 2001 to that in 2002?
Give a very brief answer. 0.98. What is the ratio of the Vaccinated children(%) of Austria in 2001 to that in 2002?
Your response must be concise. 1.01. What is the ratio of the Vaccinated children(%) in Lithuania in 2001 to that in 2002?
Give a very brief answer. 0.99. What is the ratio of the Vaccinated children(%) in Spain in 2001 to that in 2002?
Make the answer very short. 0.99. What is the difference between the highest and the second highest Vaccinated children(%) of Lithuania?
Give a very brief answer. 1. What is the difference between the highest and the second highest Vaccinated children(%) in Spain?
Make the answer very short. 1. What is the difference between the highest and the lowest Vaccinated children(%) of Lithuania?
Offer a very short reply. 4. What is the difference between the highest and the lowest Vaccinated children(%) in Spain?
Your response must be concise. 7. 